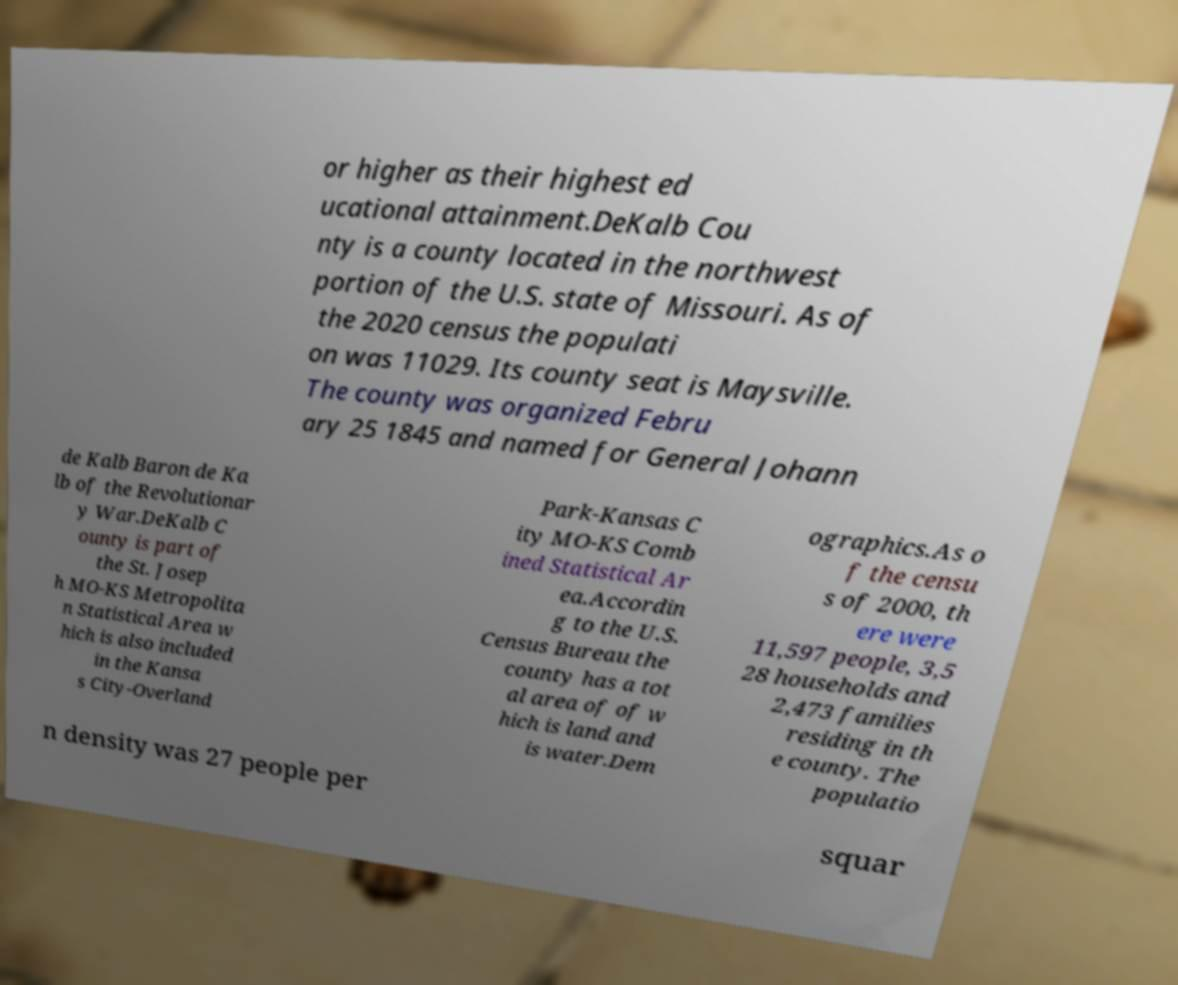Please identify and transcribe the text found in this image. or higher as their highest ed ucational attainment.DeKalb Cou nty is a county located in the northwest portion of the U.S. state of Missouri. As of the 2020 census the populati on was 11029. Its county seat is Maysville. The county was organized Febru ary 25 1845 and named for General Johann de Kalb Baron de Ka lb of the Revolutionar y War.DeKalb C ounty is part of the St. Josep h MO-KS Metropolita n Statistical Area w hich is also included in the Kansa s City-Overland Park-Kansas C ity MO-KS Comb ined Statistical Ar ea.Accordin g to the U.S. Census Bureau the county has a tot al area of of w hich is land and is water.Dem ographics.As o f the censu s of 2000, th ere were 11,597 people, 3,5 28 households and 2,473 families residing in th e county. The populatio n density was 27 people per squar 